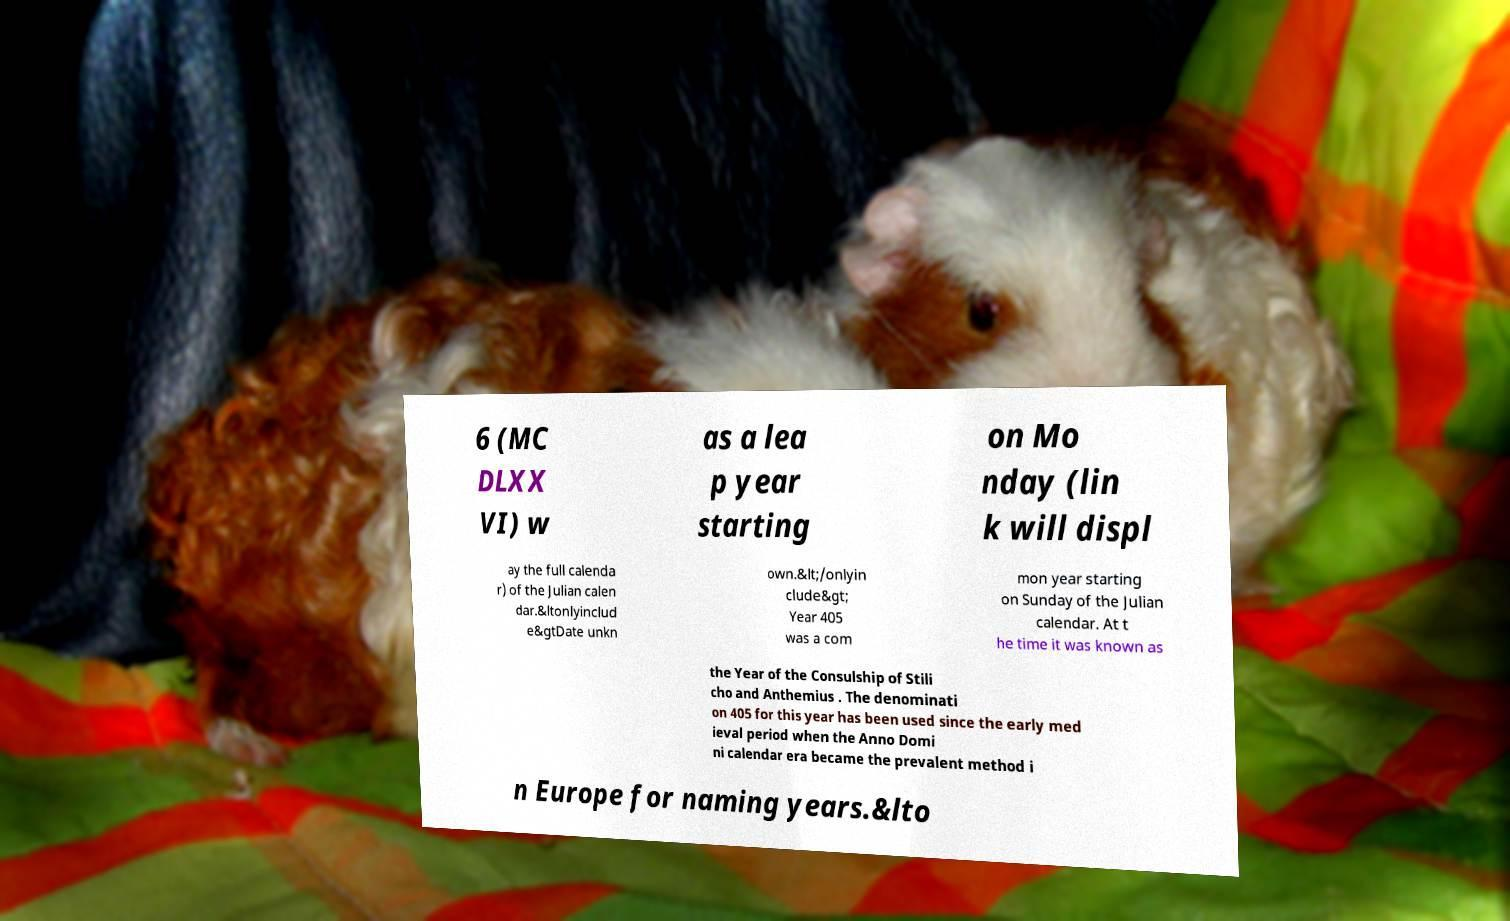Please read and relay the text visible in this image. What does it say? 6 (MC DLXX VI) w as a lea p year starting on Mo nday (lin k will displ ay the full calenda r) of the Julian calen dar.&ltonlyinclud e&gtDate unkn own.&lt;/onlyin clude&gt; Year 405 was a com mon year starting on Sunday of the Julian calendar. At t he time it was known as the Year of the Consulship of Stili cho and Anthemius . The denominati on 405 for this year has been used since the early med ieval period when the Anno Domi ni calendar era became the prevalent method i n Europe for naming years.&lto 